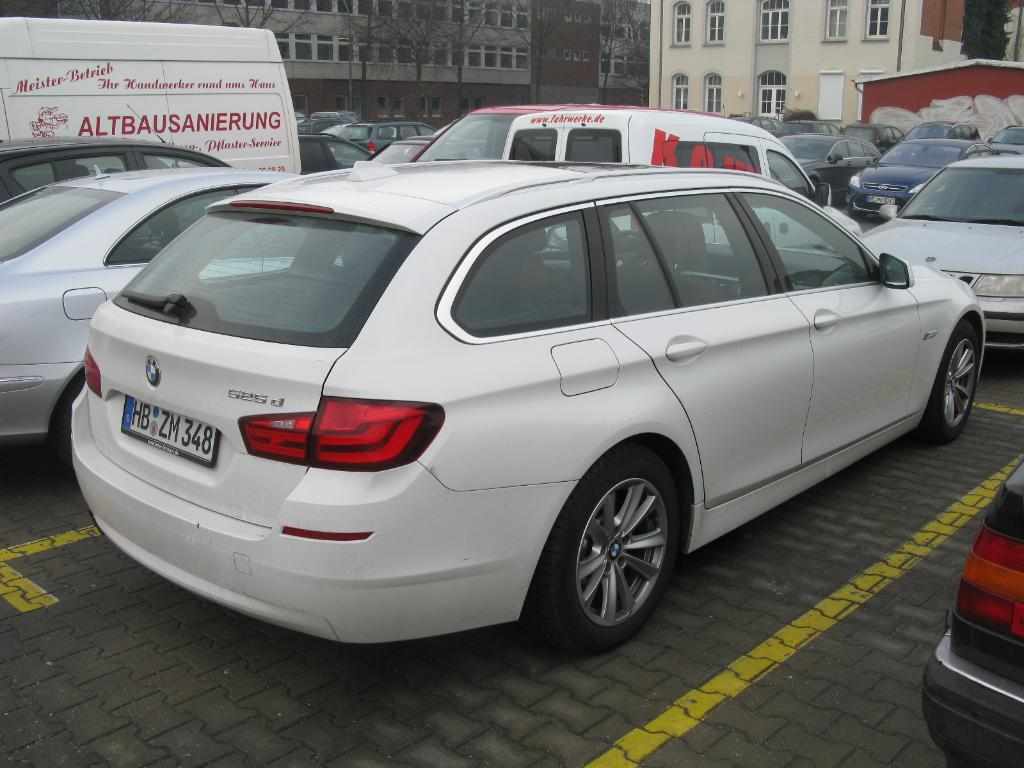What types of objects can be seen in the image? There are vehicles, trees, and buildings in the image. Can you describe any specific features of the buildings? Yes, there are windows in the image, which are features of the buildings. What color is the pen held by the giraffe in the image? There is no giraffe or pen present in the image. 